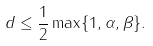<formula> <loc_0><loc_0><loc_500><loc_500>d \leq \frac { 1 } { 2 } \max \{ 1 , \alpha , \beta \} .</formula> 